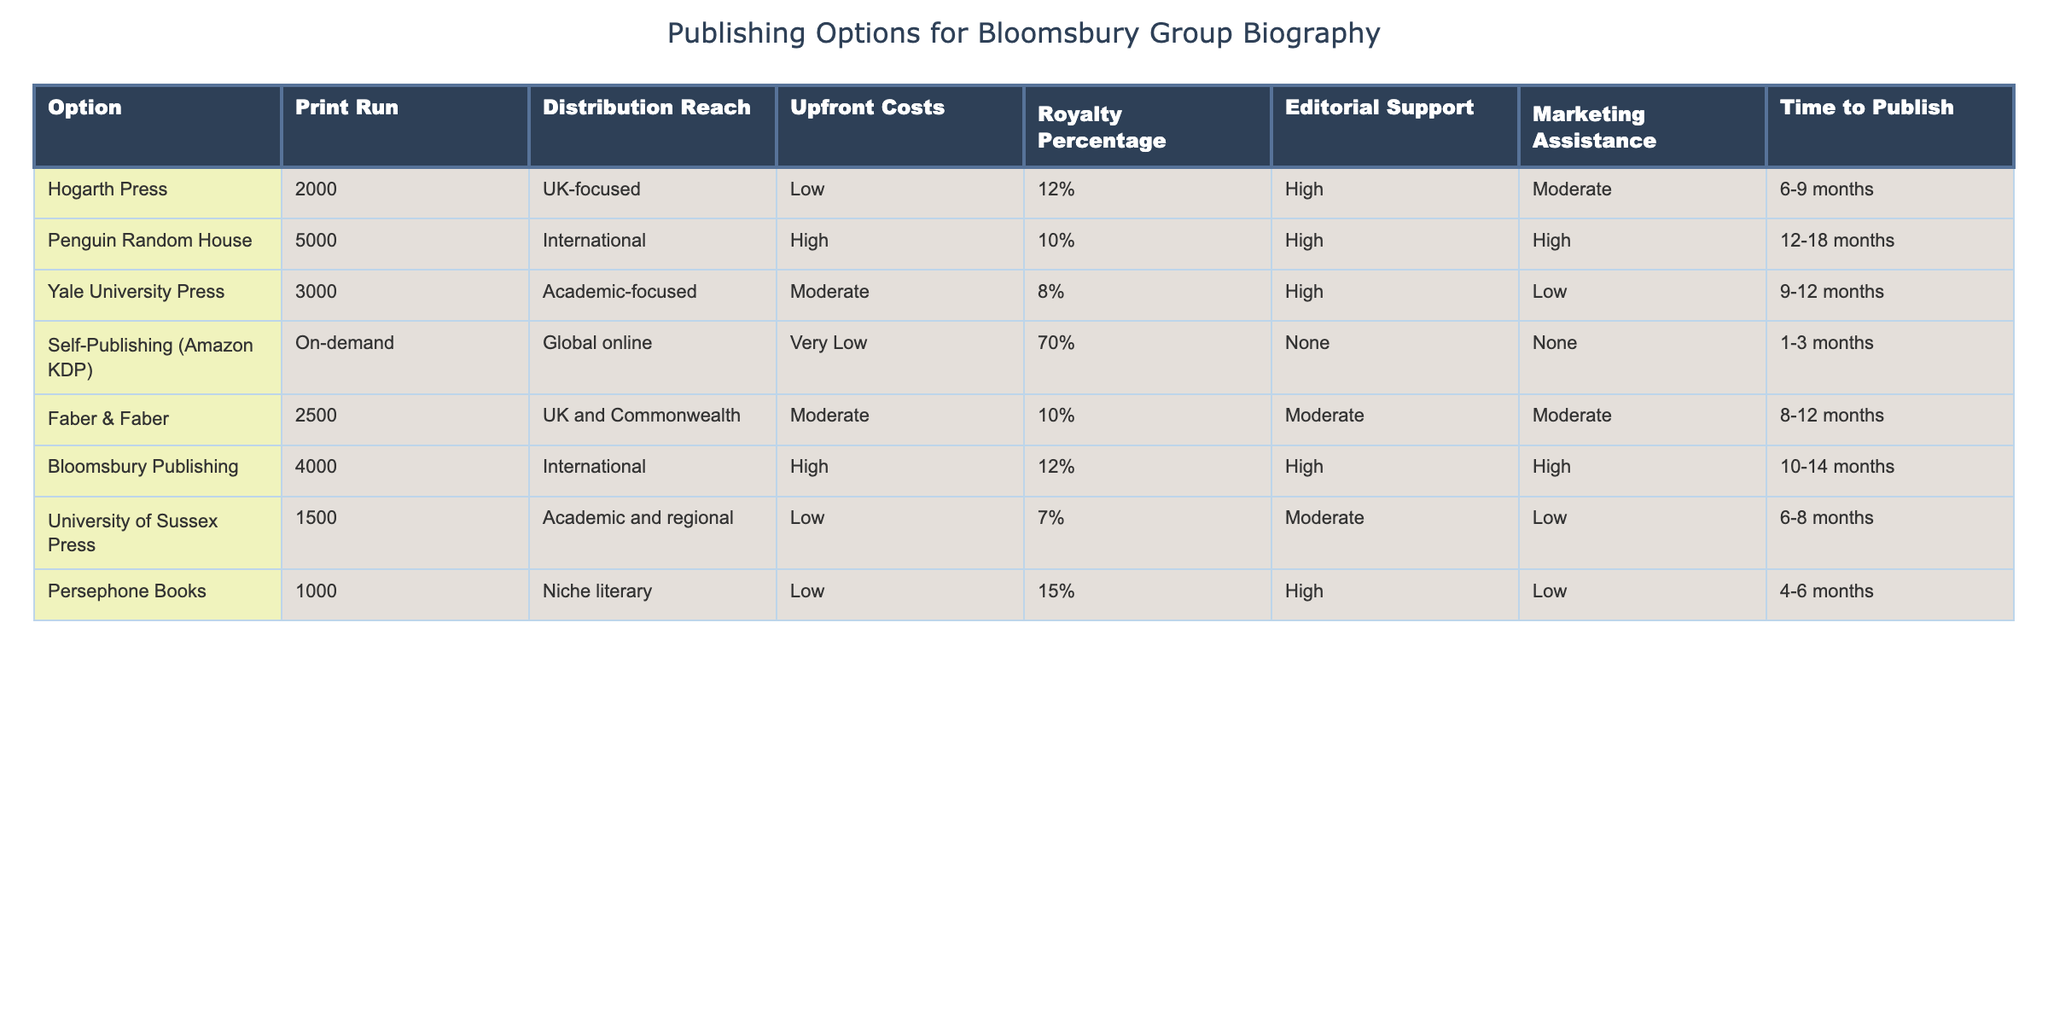What is the distribution reach of Yale University Press? According to the table, Yale University Press is categorized as "Academic-focused," which indicates its target audience and market scope.
Answer: Academic-focused How many print runs does Persephone Books offer? The table specifies that Persephone Books offers a print run of 1000 copies.
Answer: 1000 Which publishing option has the highest royalty percentage? By examining the table, Self-Publishing (Amazon KDP) has the highest royalty percentage, which is 70%.
Answer: 70% What is the average upfront cost for publishing options that offer high editorial support? The options offering high editorial support are Hogarth Press, Penguin Random House, Yale University Press, Bloomsbury Publishing. Their upfront costs are Low, High, Moderate, and High respectively, which we categorize as values of 1, 3, 2, and 3. The average is (1 + 3 + 2 + 3) / 4 = 2.25. Thus, the average would be classified as Moderate.
Answer: Moderate Is there a publishing option with both high marketing assistance and low editorial support? Looking through the table, there is no option that fits this criterion. All options with high marketing assistance also provide high editorial support or moderate support.
Answer: No Which publishing options take less than 10 months to publish? By reviewing the time to publish column, the options with a timeframe less than 10 months are Self-Publishing (1-3 months), University of Sussex Press (6-8 months), and Persephone Books (4-6 months). Therefore, there are three options.
Answer: Three options If I wanted to maximize distribution reach, which publishing option should I choose? The option with the highest distribution reach is Penguin Random House, which is categorized as "International." Looking at the data, it also has a large print run of 5000 copies.
Answer: Penguin Random House What is the difference in royalty percentage between the highest and the lowest options? Self-Publishing (Amazon KDP) has the highest royalty percentage at 70%, and University of Sussex Press has the lowest at 7%. The difference is 70% - 7% = 63%.
Answer: 63% Which publishing option has the longest time to publish? The longest time to publish is with Penguin Random House, which ranges from 12 to 18 months based on the table.
Answer: 12-18 months 